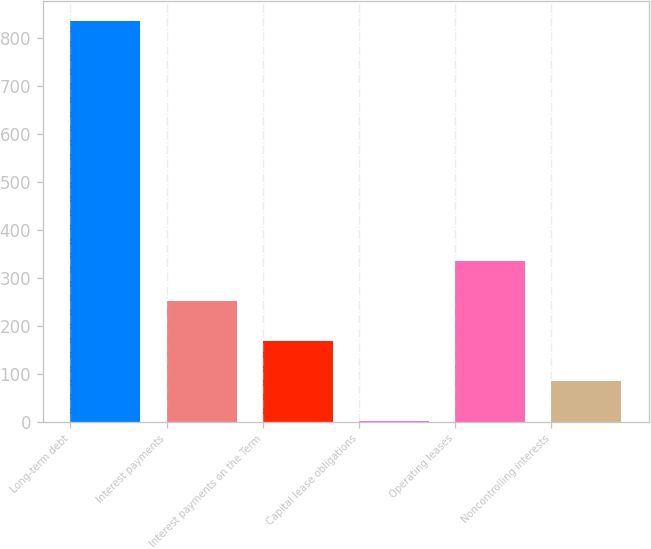Convert chart to OTSL. <chart><loc_0><loc_0><loc_500><loc_500><bar_chart><fcel>Long-term debt<fcel>Interest payments<fcel>Interest payments on the Term<fcel>Capital lease obligations<fcel>Operating leases<fcel>Noncontrolling interests<nl><fcel>835<fcel>251.2<fcel>167.8<fcel>1<fcel>334.6<fcel>84.4<nl></chart> 